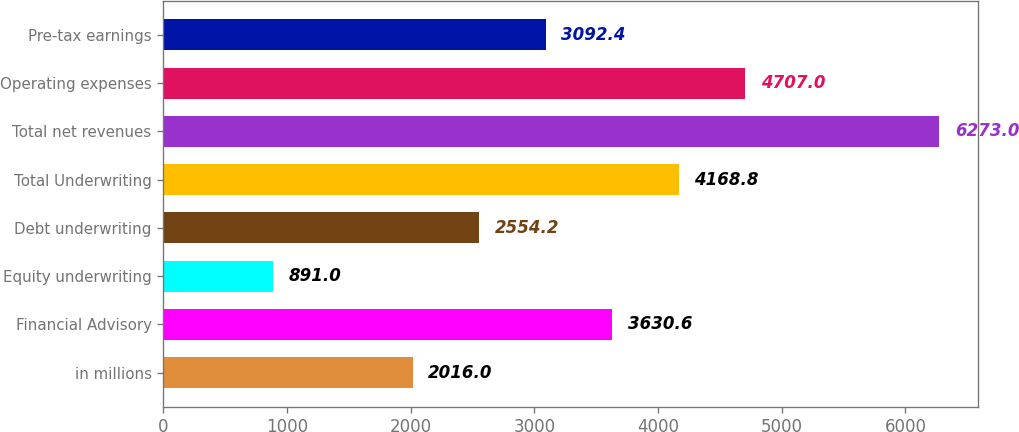<chart> <loc_0><loc_0><loc_500><loc_500><bar_chart><fcel>in millions<fcel>Financial Advisory<fcel>Equity underwriting<fcel>Debt underwriting<fcel>Total Underwriting<fcel>Total net revenues<fcel>Operating expenses<fcel>Pre-tax earnings<nl><fcel>2016<fcel>3630.6<fcel>891<fcel>2554.2<fcel>4168.8<fcel>6273<fcel>4707<fcel>3092.4<nl></chart> 